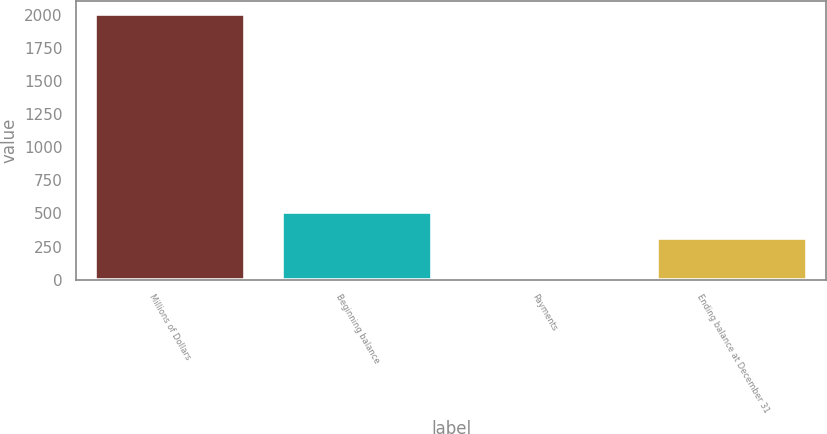Convert chart. <chart><loc_0><loc_0><loc_500><loc_500><bar_chart><fcel>Millions of Dollars<fcel>Beginning balance<fcel>Payments<fcel>Ending balance at December 31<nl><fcel>2005<fcel>510.2<fcel>13<fcel>311<nl></chart> 